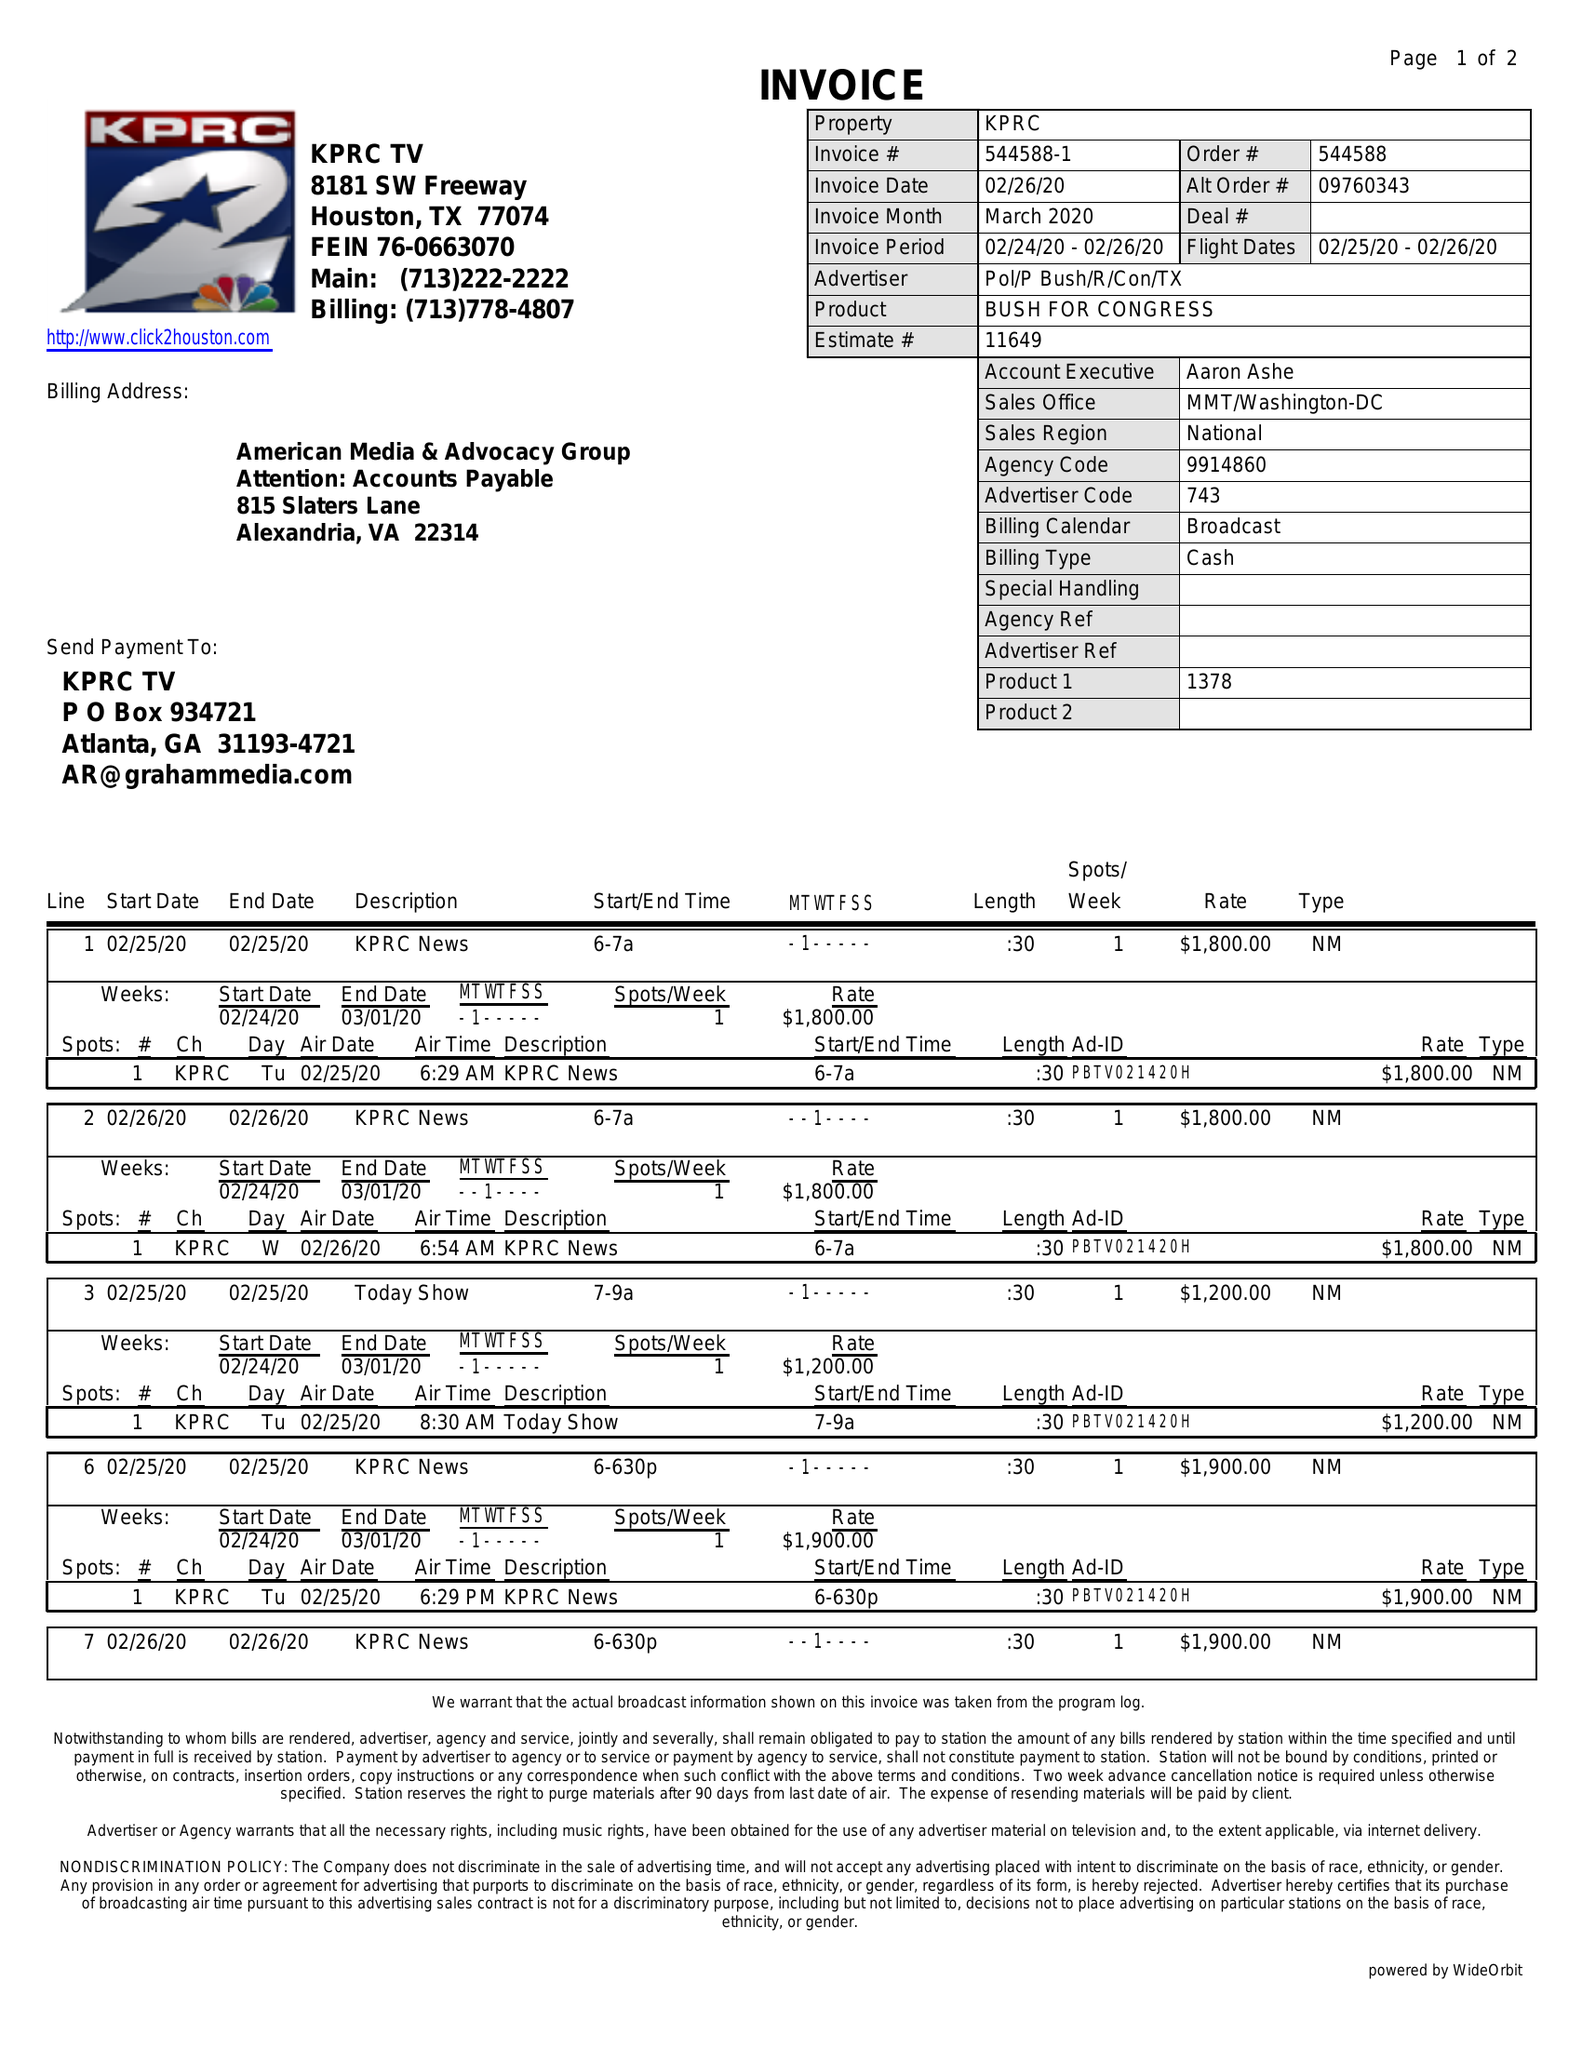What is the value for the contract_num?
Answer the question using a single word or phrase. 544588 